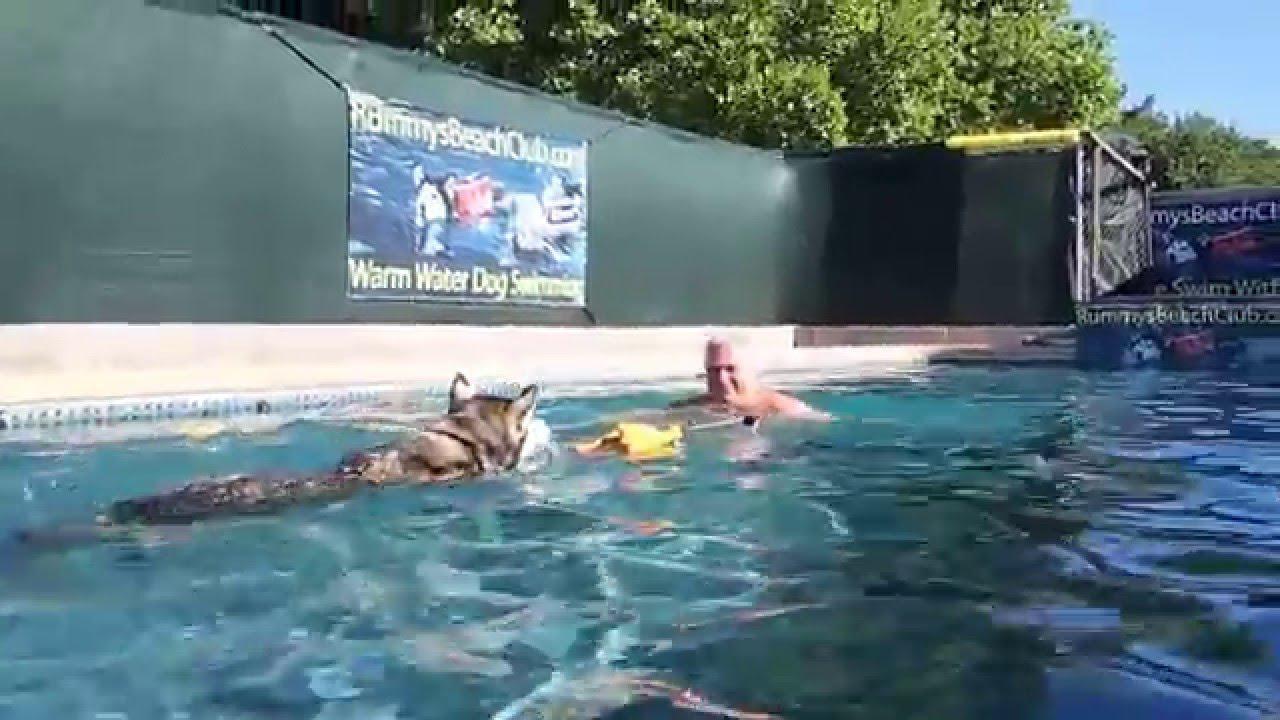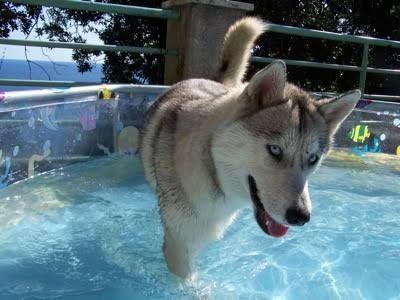The first image is the image on the left, the second image is the image on the right. Analyze the images presented: Is the assertion "In one image, a dog is alone in shallow pool water, but in the second image, a dog is with a man in deeper water." valid? Answer yes or no. Yes. The first image is the image on the left, the second image is the image on the right. Examine the images to the left and right. Is the description "In at least one image there is a husky swimming in a pool with a man only wearing shorts." accurate? Answer yes or no. Yes. 